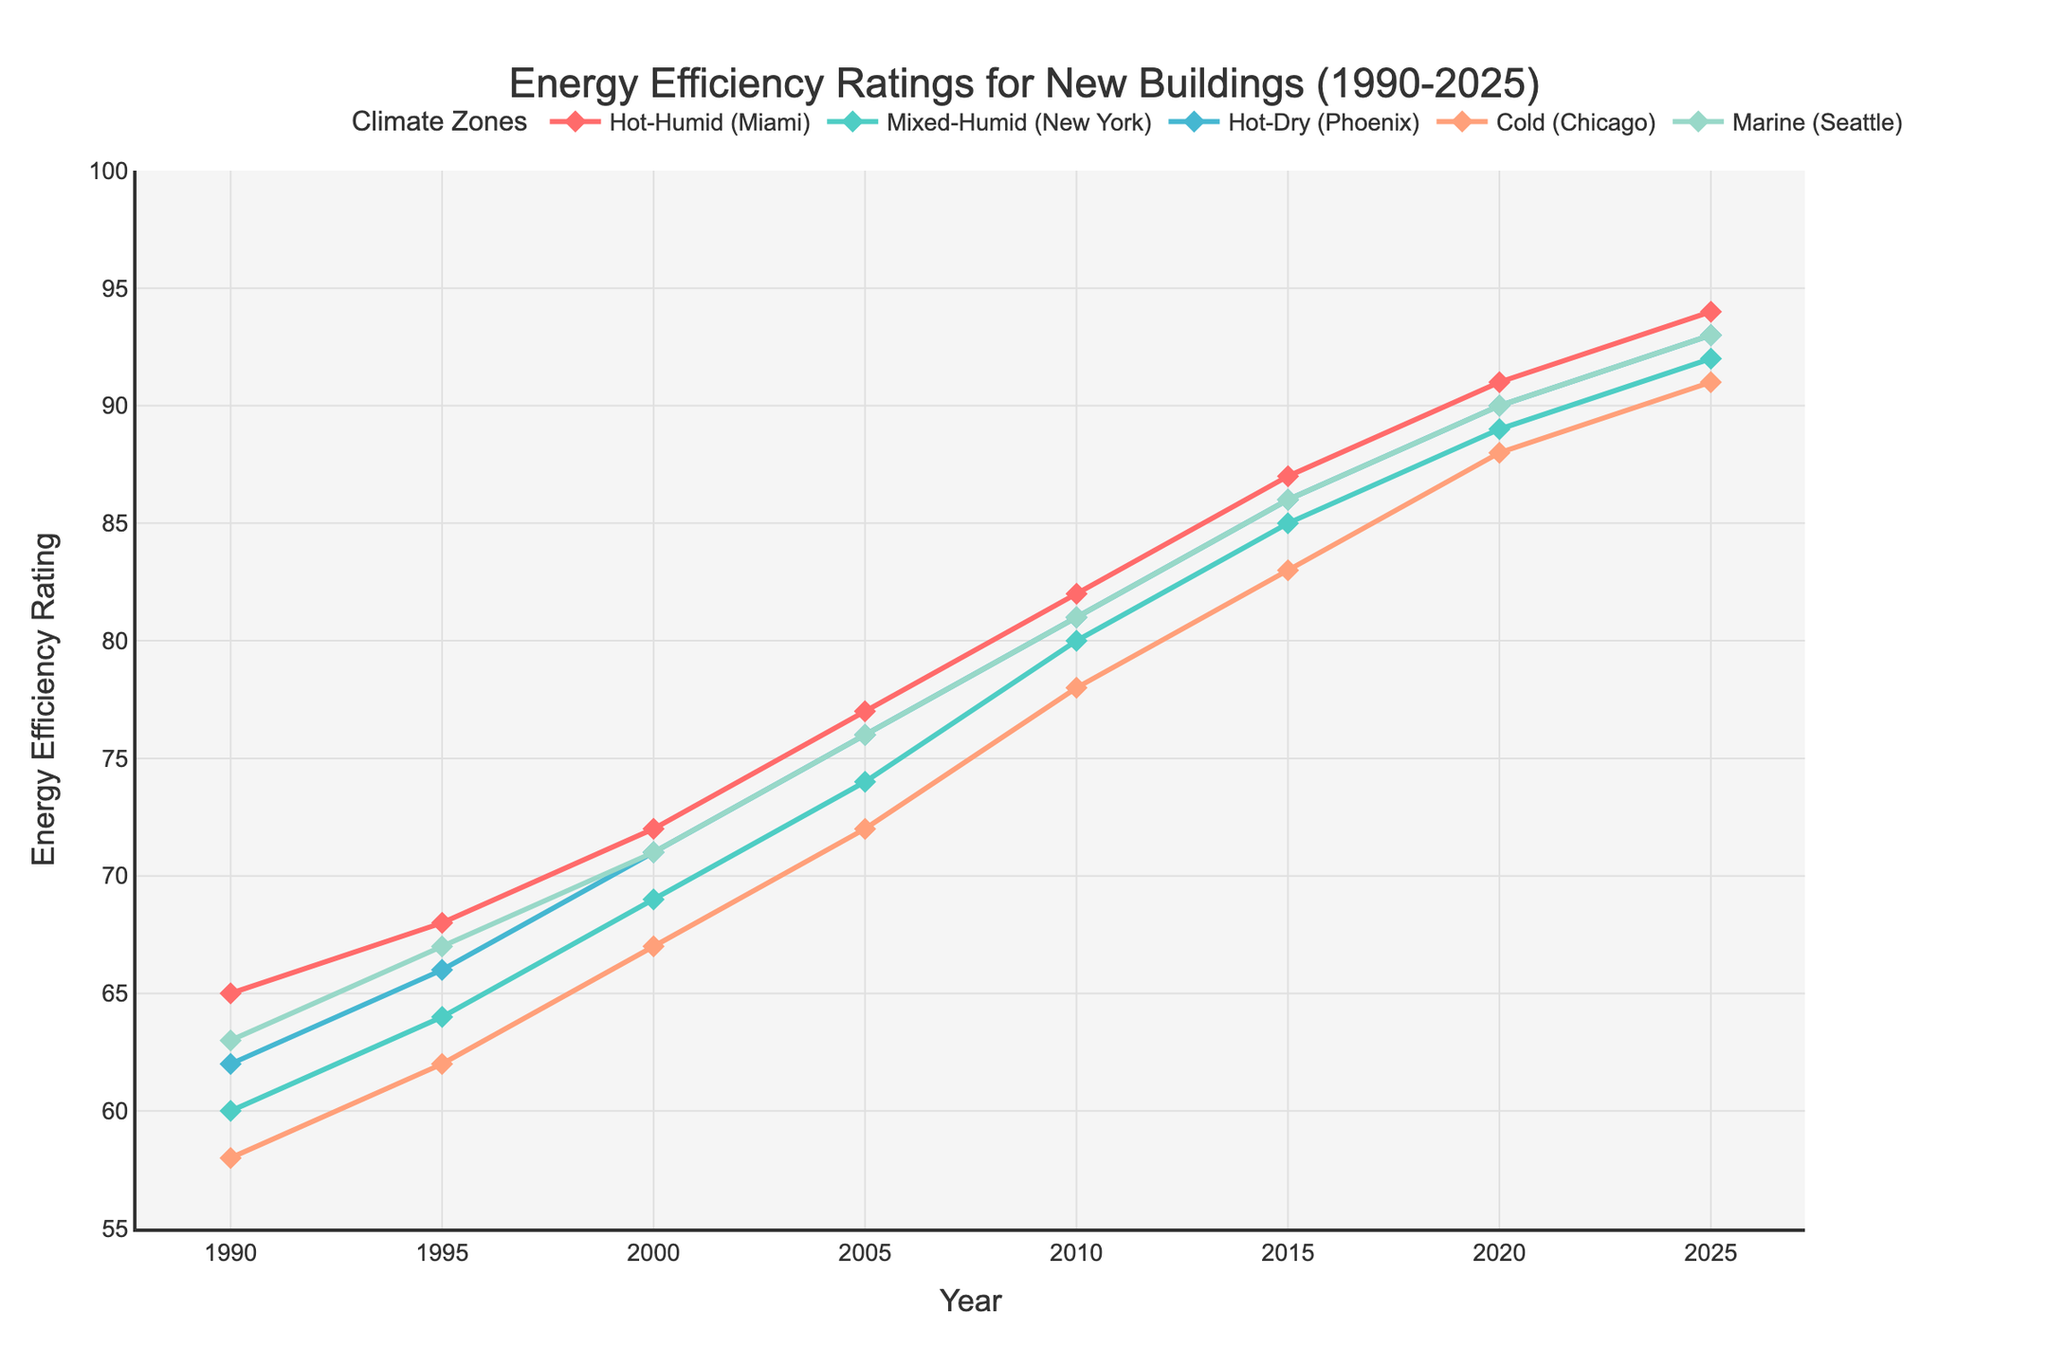What's the trend in energy efficiency ratings for the Cold (Chicago) climate zone from 1990 to 2025? The energy efficiency rating in the Cold (Chicago) climate zone shows a consistent upward trend from 58 in 1990 to 91 in 2025.
Answer: It increases Which climate zone shows the highest energy efficiency rating in 2020? To find this, look at the values for each climate zone in 2020. The values are: Hot-Humid (91), Mixed-Humid (89), Hot-Dry (90), Cold (88), and Marine (90). The highest is Hot-Humid (Miami) with 91.
Answer: Hot-Humid (Miami) By how much did the energy efficiency rating improve in the Hot-Dry (Phoenix) climate zone from 1990 to 2020? Subtract the 1990 rating (62) from the 2020 rating (90) for Hot-Dry (Phoenix): 90 - 62 = 28.
Answer: 28 Which climate zone has the most consistent increase in energy efficiency ratings over the last 30 years? Observing the lines' slopes, all zones show a steady increase, but Marine (Seattle) appears to have the most uniformly spaced increments between each year, suggesting the most consistent increase.
Answer: Marine (Seattle) In what year did the Hot-Dry (Phoenix) climate zone surpass 70 in energy efficiency rating? Reviewing the data, the Hot-Dry (Phoenix) climate zone surpasses 70 in 2000 with a rating of 71.
Answer: 2000 What is the range of energy efficiency ratings in the year 2005 for all climate zones? To find the range, subtract the lowest value from the highest value in 2005: Highest (Hot-Dry 76) - Lowest (Cold 72) = 76 - 72 = 4.
Answer: 4 What is the average energy efficiency rating of the Mixed-Humid (New York) climate zone across all years? Sum the ratings from 1990 to 2025: 60 + 64 + 69 + 74 + 80 + 85 + 89 + 92 = 613. Divide by the number of years (8): 613 / 8 = 76.625.
Answer: 76.625 Which climate zone shows a higher rate of increase in energy efficiency between 2010 and 2020, Hot-Humid (Miami) or Cold (Chicago)? Calculate the differences between 2010 and 2020 for each zone: Hot-Humid (91 - 82 = 9), Cold (88 - 78 = 10). Cold (Chicago) has a higher increase of 10 compared to 9 for Hot-Humid.
Answer: Cold (Chicago) Describe the color and shape of the markers used for the Marine (Seattle) climate zone in the plot. The marker for the Marine (Seattle) climate zone is a diamond shape and is colored light blue.
Answer: light blue, diamond 